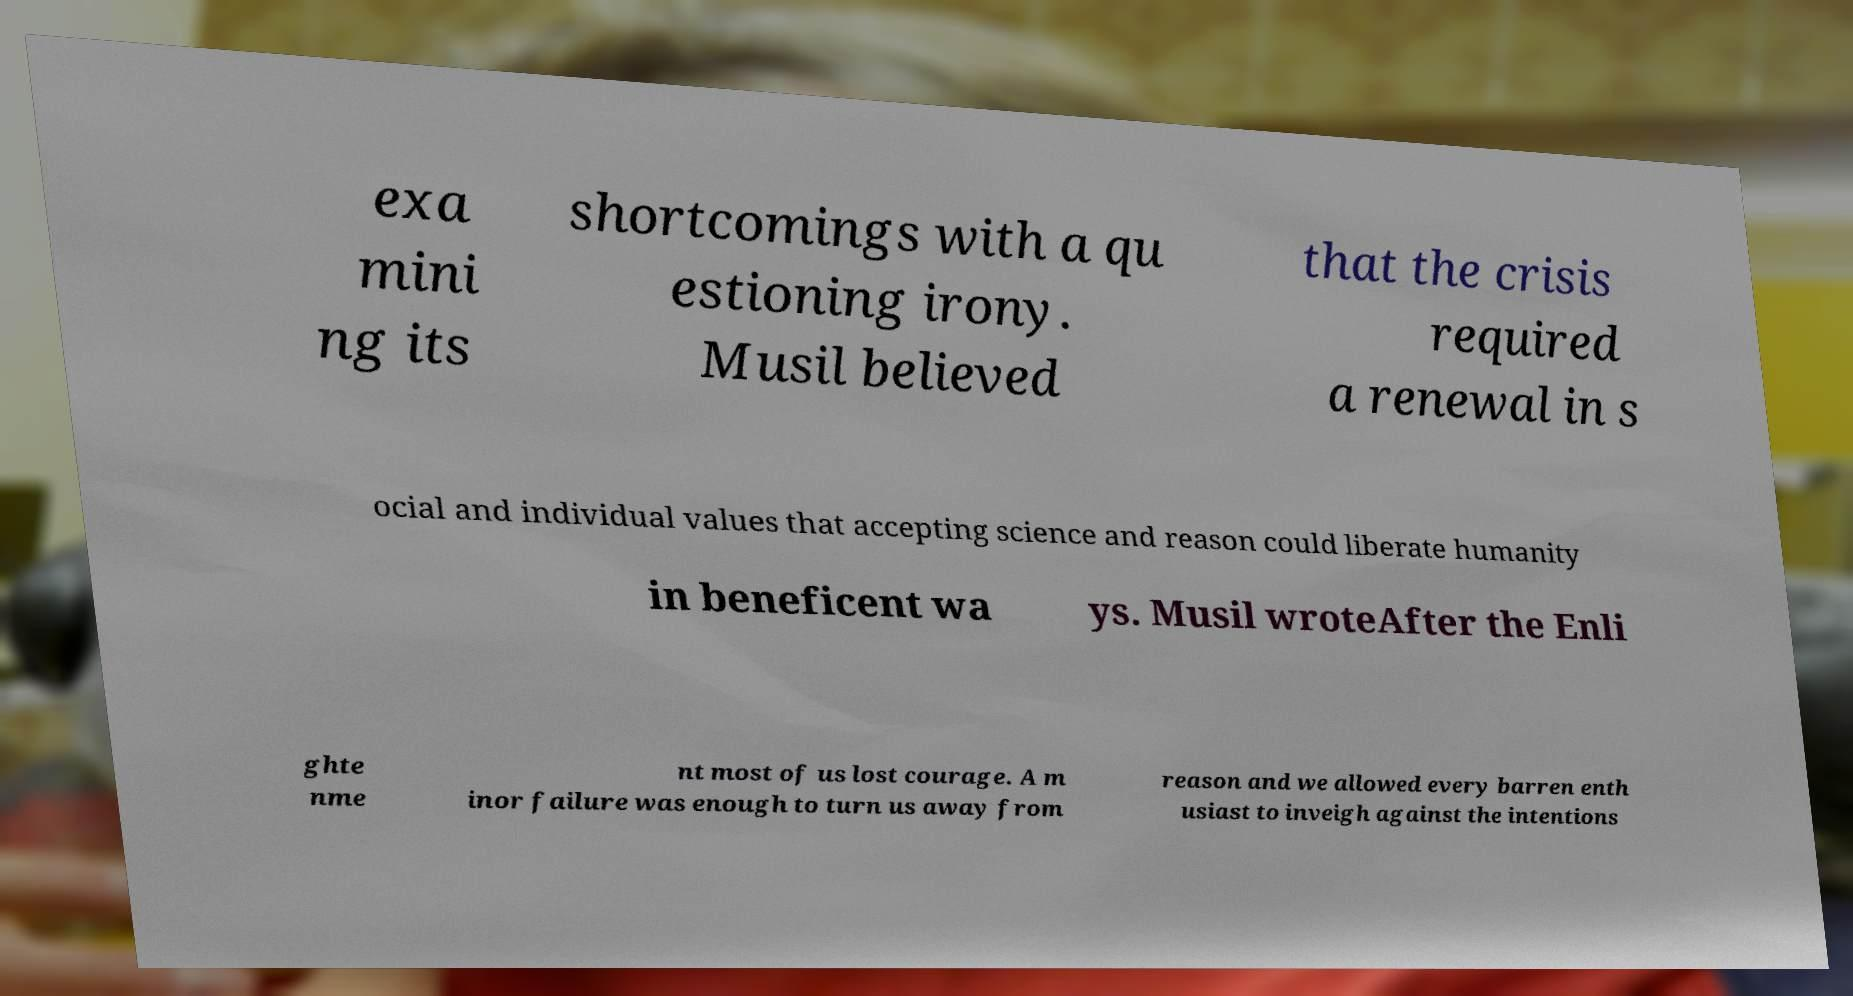For documentation purposes, I need the text within this image transcribed. Could you provide that? exa mini ng its shortcomings with a qu estioning irony. Musil believed that the crisis required a renewal in s ocial and individual values that accepting science and reason could liberate humanity in beneficent wa ys. Musil wroteAfter the Enli ghte nme nt most of us lost courage. A m inor failure was enough to turn us away from reason and we allowed every barren enth usiast to inveigh against the intentions 